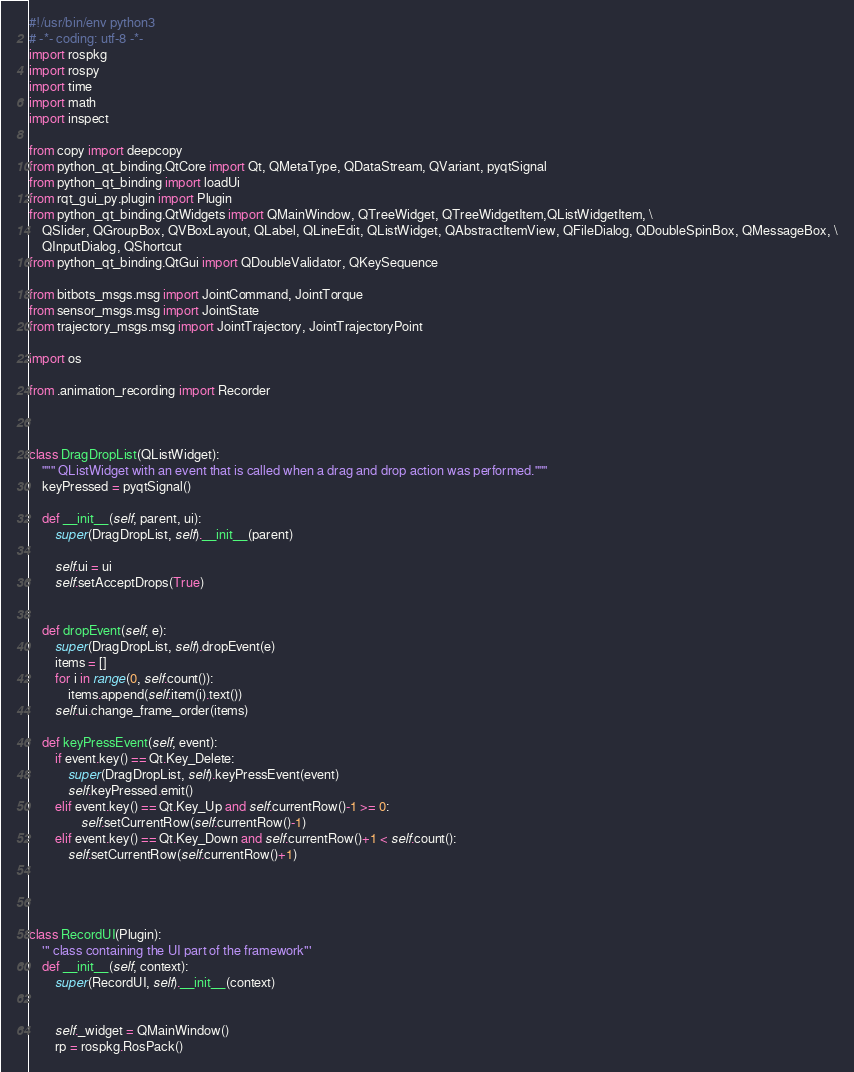Convert code to text. <code><loc_0><loc_0><loc_500><loc_500><_Python_>#!/usr/bin/env python3
# -*- coding: utf-8 -*-
import rospkg
import rospy
import time
import math
import inspect

from copy import deepcopy
from python_qt_binding.QtCore import Qt, QMetaType, QDataStream, QVariant, pyqtSignal
from python_qt_binding import loadUi
from rqt_gui_py.plugin import Plugin
from python_qt_binding.QtWidgets import QMainWindow, QTreeWidget, QTreeWidgetItem,QListWidgetItem, \
    QSlider, QGroupBox, QVBoxLayout, QLabel, QLineEdit, QListWidget, QAbstractItemView, QFileDialog, QDoubleSpinBox, QMessageBox, \
    QInputDialog, QShortcut
from python_qt_binding.QtGui import QDoubleValidator, QKeySequence

from bitbots_msgs.msg import JointCommand, JointTorque
from sensor_msgs.msg import JointState
from trajectory_msgs.msg import JointTrajectory, JointTrajectoryPoint

import os

from .animation_recording import Recorder



class DragDropList(QListWidget):
    """ QListWidget with an event that is called when a drag and drop action was performed."""
    keyPressed = pyqtSignal()

    def __init__(self, parent, ui):
        super(DragDropList, self).__init__(parent)

        self.ui = ui
        self.setAcceptDrops(True)


    def dropEvent(self, e):
        super(DragDropList, self).dropEvent(e)
        items = []
        for i in range(0, self.count()):
            items.append(self.item(i).text())
        self.ui.change_frame_order(items)

    def keyPressEvent(self, event):
        if event.key() == Qt.Key_Delete:
            super(DragDropList, self).keyPressEvent(event)
            self.keyPressed.emit()
        elif event.key() == Qt.Key_Up and self.currentRow()-1 >= 0:
                self.setCurrentRow(self.currentRow()-1)
        elif event.key() == Qt.Key_Down and self.currentRow()+1 < self.count():
            self.setCurrentRow(self.currentRow()+1)




class RecordUI(Plugin):
    ''' class containing the UI part of the framework'''
    def __init__(self, context):
        super(RecordUI, self).__init__(context)


        self._widget = QMainWindow()
        rp = rospkg.RosPack()</code> 